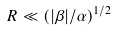Convert formula to latex. <formula><loc_0><loc_0><loc_500><loc_500>R \ll \left ( | \beta | / \alpha \right ) ^ { 1 / 2 }</formula> 